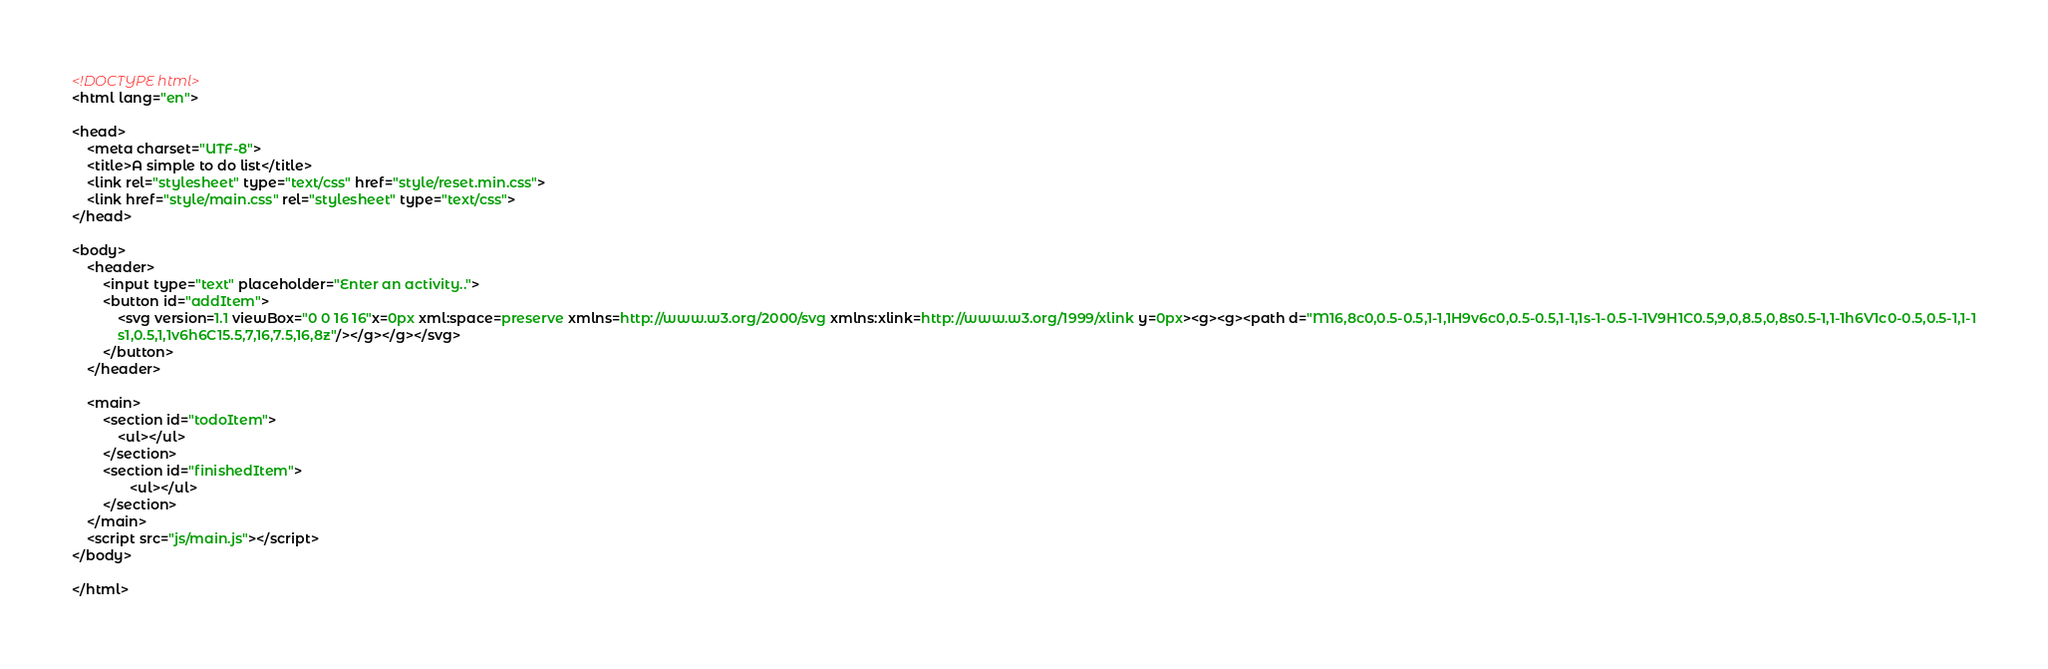Convert code to text. <code><loc_0><loc_0><loc_500><loc_500><_HTML_><!DOCTYPE html>
<html lang="en">

<head>
    <meta charset="UTF-8">
    <title>A simple to do list</title>
    <link rel="stylesheet" type="text/css" href="style/reset.min.css">
    <link href="style/main.css" rel="stylesheet" type="text/css">
</head>

<body>
    <header>
        <input type="text" placeholder="Enter an activity..">
        <button id="addItem">
            <svg version=1.1 viewBox="0 0 16 16"x=0px xml:space=preserve xmlns=http://www.w3.org/2000/svg xmlns:xlink=http://www.w3.org/1999/xlink y=0px><g><g><path d="M16,8c0,0.5-0.5,1-1,1H9v6c0,0.5-0.5,1-1,1s-1-0.5-1-1V9H1C0.5,9,0,8.5,0,8s0.5-1,1-1h6V1c0-0.5,0.5-1,1-1
			s1,0.5,1,1v6h6C15.5,7,16,7.5,16,8z"/></g></g></svg>
        </button>
    </header>

    <main>
        <section id="todoItem">
            <ul></ul>
        </section>
        <section id="finishedItem">
               <ul></ul>
        </section>
    </main>
    <script src="js/main.js"></script>
</body>

</html></code> 